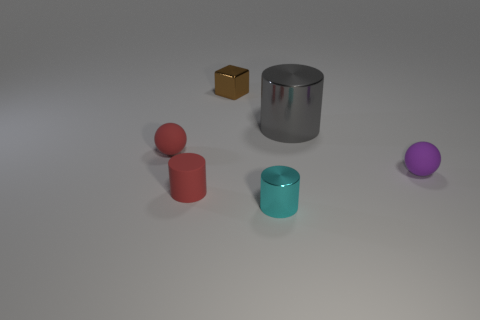Is the number of red rubber balls on the right side of the red ball less than the number of small matte cylinders that are behind the small cyan shiny cylinder?
Your answer should be compact. Yes. Is the number of tiny red objects that are behind the big shiny cylinder less than the number of big cyan objects?
Offer a very short reply. No. What is the material of the ball that is in front of the tiny matte sphere that is left of the ball right of the cyan metallic thing?
Ensure brevity in your answer.  Rubber. How many things are either objects that are to the left of the big metal cylinder or small red matte objects that are behind the small purple rubber ball?
Offer a very short reply. 4. What is the material of the other tiny thing that is the same shape as the cyan thing?
Your answer should be very brief. Rubber. How many metallic objects are tiny purple spheres or brown cylinders?
Ensure brevity in your answer.  0. There is a small cyan object that is made of the same material as the large thing; what is its shape?
Make the answer very short. Cylinder. What number of tiny red things are the same shape as the purple object?
Your response must be concise. 1. Does the shiny object that is in front of the large gray thing have the same shape as the large gray metal thing that is right of the red cylinder?
Your answer should be very brief. Yes. What number of objects are red cylinders or purple matte balls that are right of the big gray shiny object?
Ensure brevity in your answer.  2. 